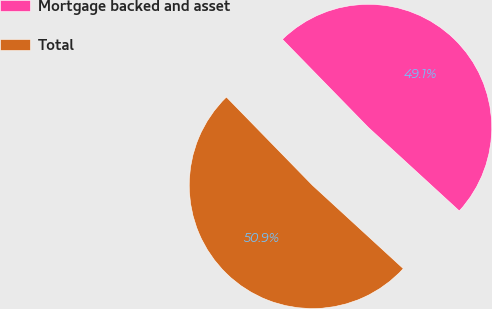Convert chart to OTSL. <chart><loc_0><loc_0><loc_500><loc_500><pie_chart><fcel>Mortgage backed and asset<fcel>Total<nl><fcel>49.12%<fcel>50.88%<nl></chart> 